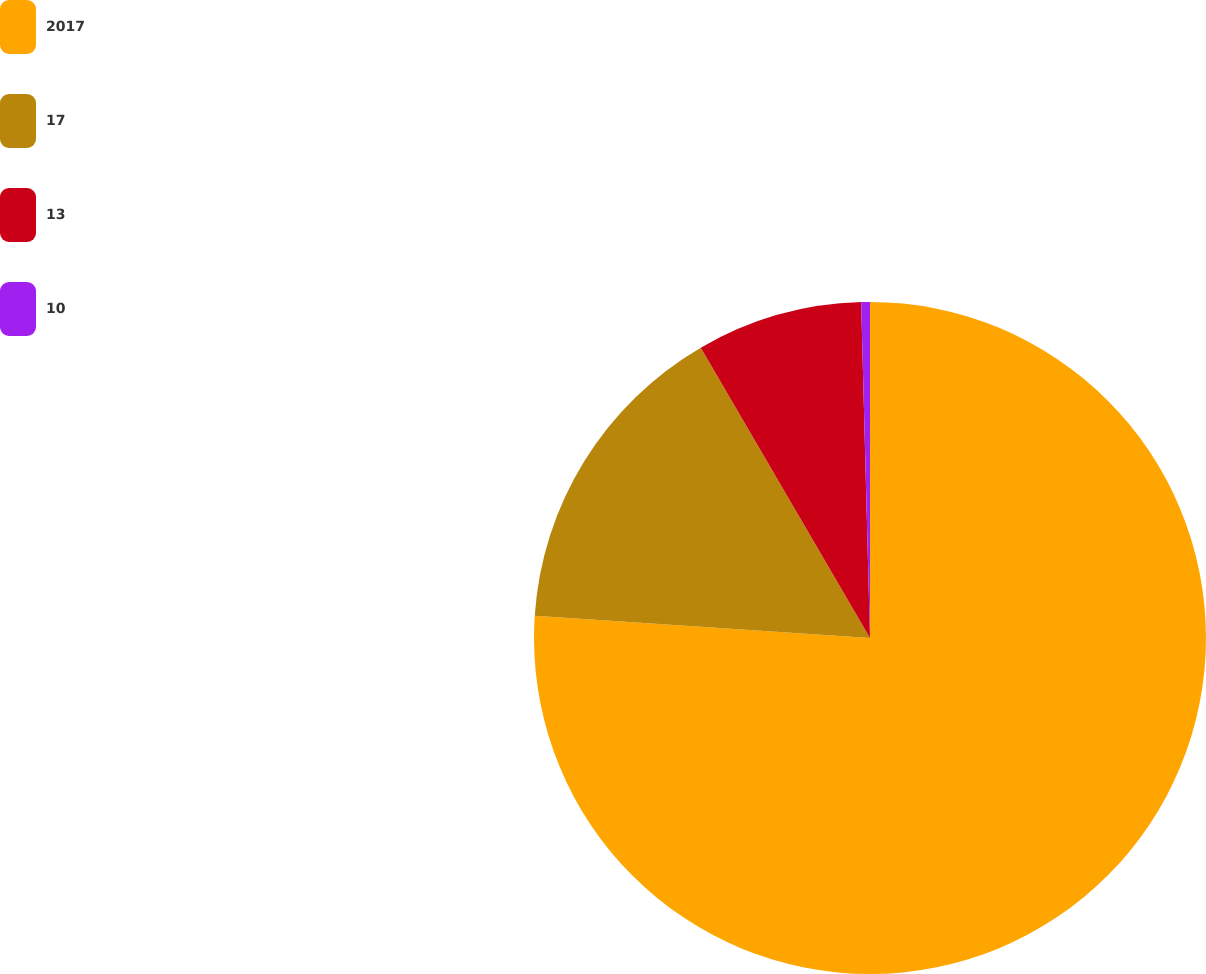Convert chart to OTSL. <chart><loc_0><loc_0><loc_500><loc_500><pie_chart><fcel>2017<fcel>17<fcel>13<fcel>10<nl><fcel>76.06%<fcel>15.54%<fcel>7.98%<fcel>0.42%<nl></chart> 